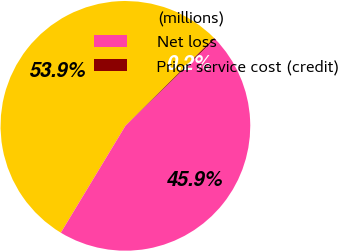<chart> <loc_0><loc_0><loc_500><loc_500><pie_chart><fcel>(millions)<fcel>Net loss<fcel>Prior service cost (credit)<nl><fcel>53.92%<fcel>45.91%<fcel>0.16%<nl></chart> 